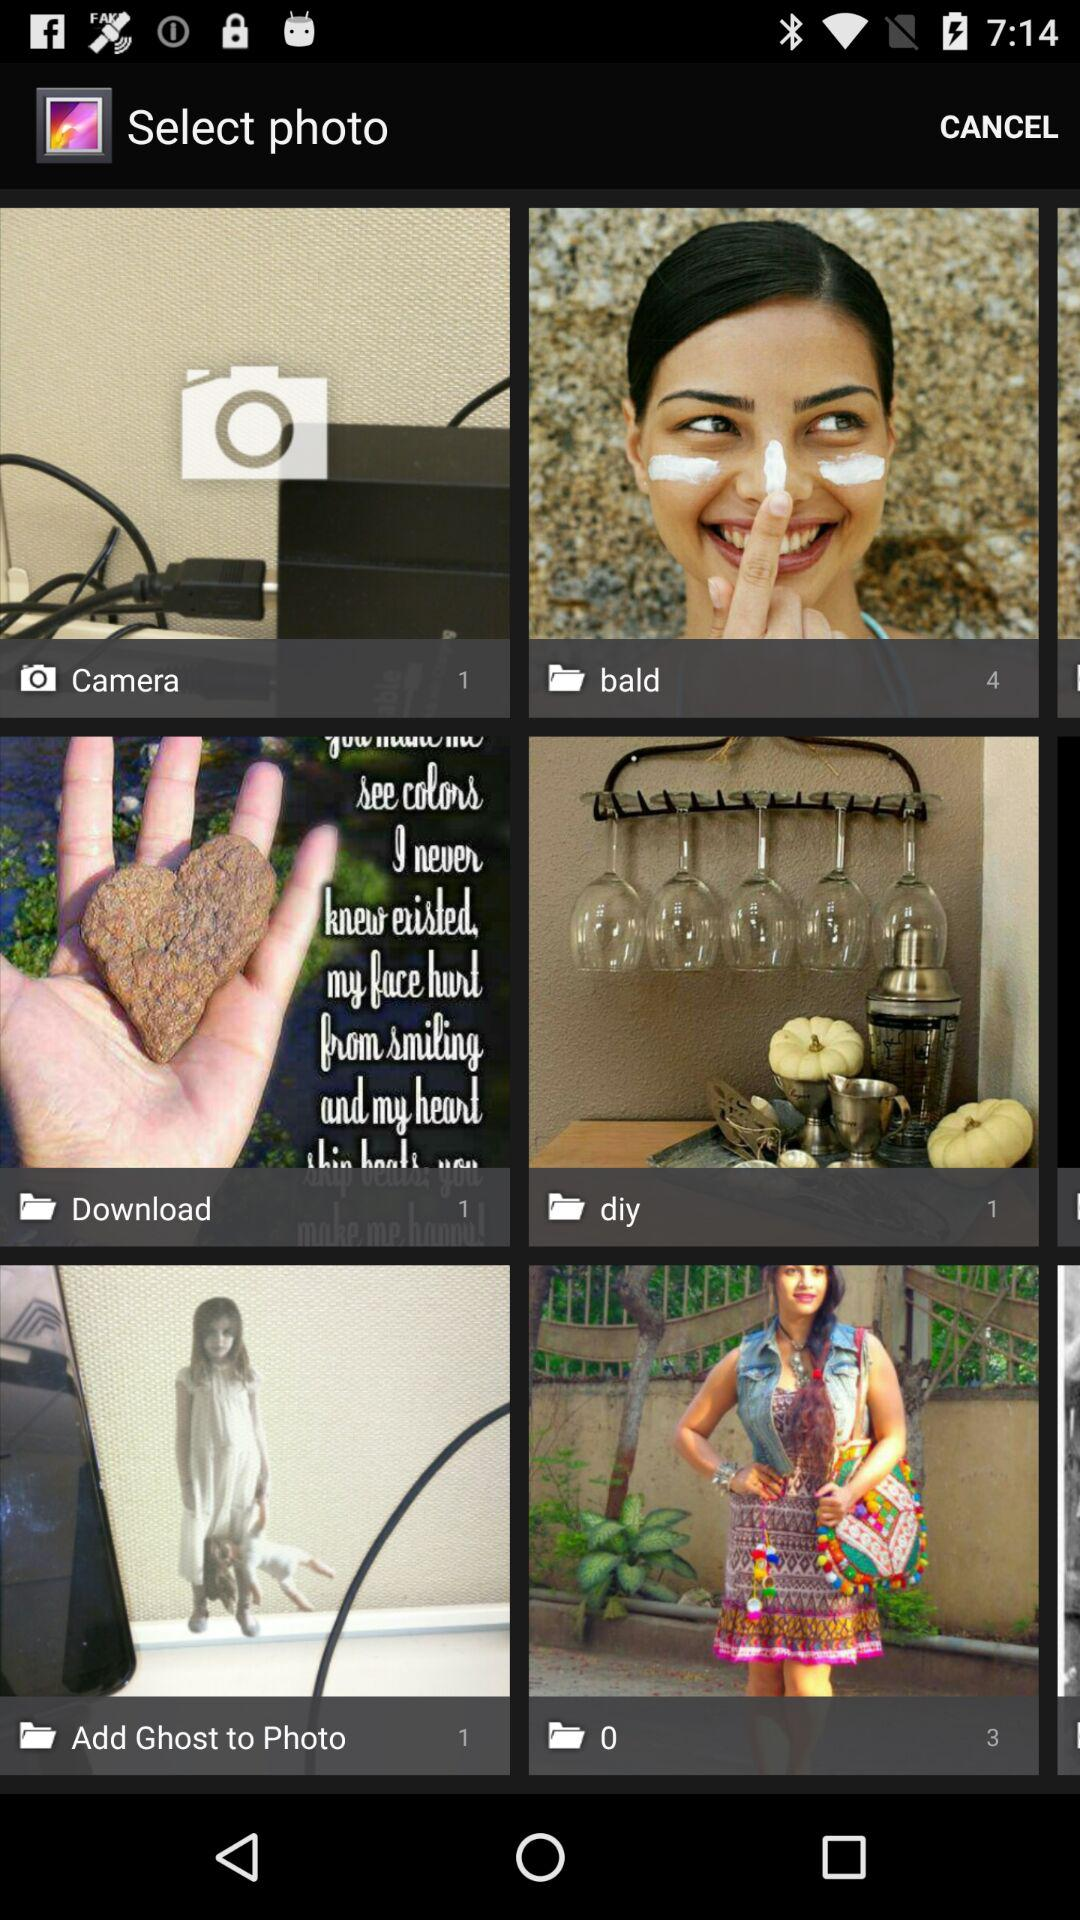What is the number of images in the folder "bald"? The number of images in the folder "bald" is 4. 